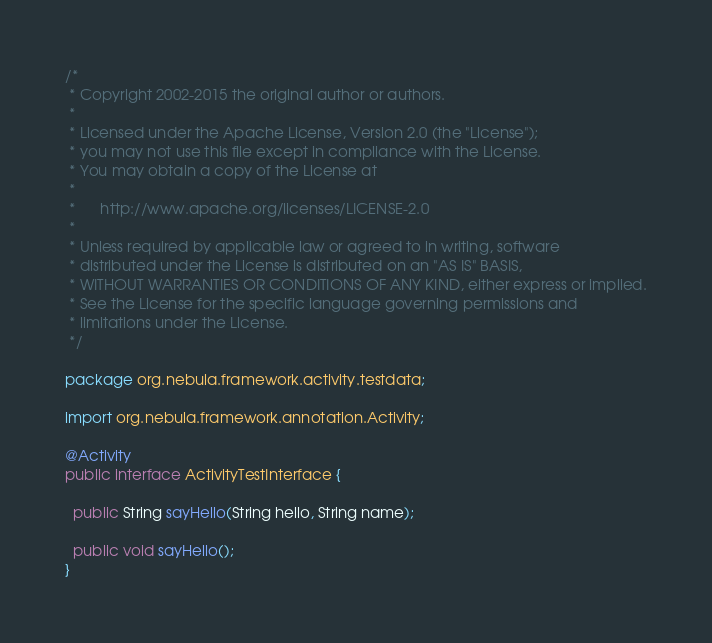<code> <loc_0><loc_0><loc_500><loc_500><_Java_>/*
 * Copyright 2002-2015 the original author or authors.
 *
 * Licensed under the Apache License, Version 2.0 (the "License");
 * you may not use this file except in compliance with the License.
 * You may obtain a copy of the License at
 *
 *      http://www.apache.org/licenses/LICENSE-2.0
 *
 * Unless required by applicable law or agreed to in writing, software
 * distributed under the License is distributed on an "AS IS" BASIS,
 * WITHOUT WARRANTIES OR CONDITIONS OF ANY KIND, either express or implied.
 * See the License for the specific language governing permissions and
 * limitations under the License.
 */

package org.nebula.framework.activity.testdata;

import org.nebula.framework.annotation.Activity;

@Activity
public interface ActivityTestInterface {

  public String sayHello(String hello, String name);

  public void sayHello();
} 
</code> 